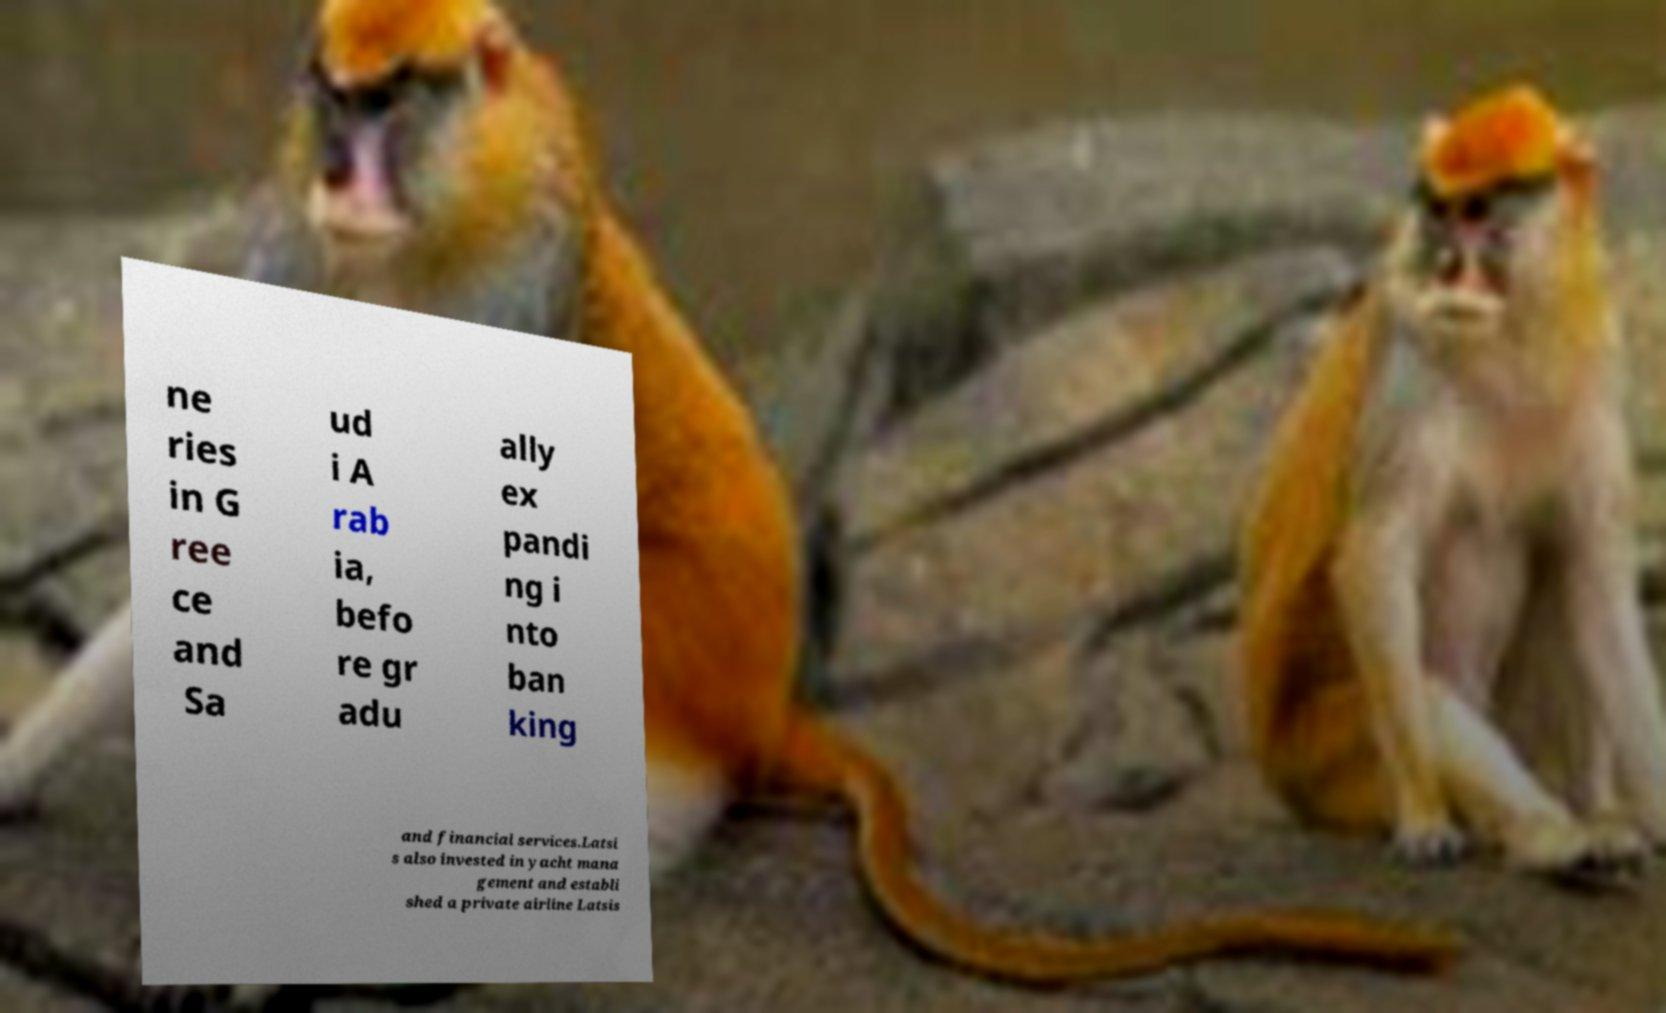I need the written content from this picture converted into text. Can you do that? ne ries in G ree ce and Sa ud i A rab ia, befo re gr adu ally ex pandi ng i nto ban king and financial services.Latsi s also invested in yacht mana gement and establi shed a private airline Latsis 